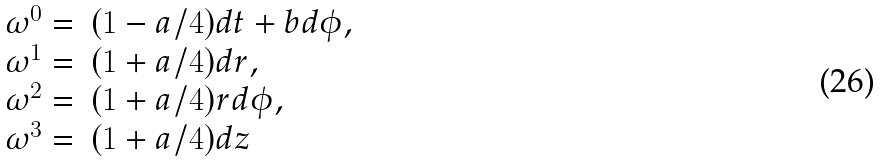Convert formula to latex. <formula><loc_0><loc_0><loc_500><loc_500>\begin{array} { l l } \omega ^ { 0 } = & ( 1 - a / 4 ) d t + b d \phi , \\ \omega ^ { 1 } = & ( 1 + a / 4 ) d r , \\ \omega ^ { 2 } = & ( 1 + a / 4 ) r d \phi , \\ \omega ^ { 3 } = & ( 1 + a / 4 ) d z \end{array}</formula> 